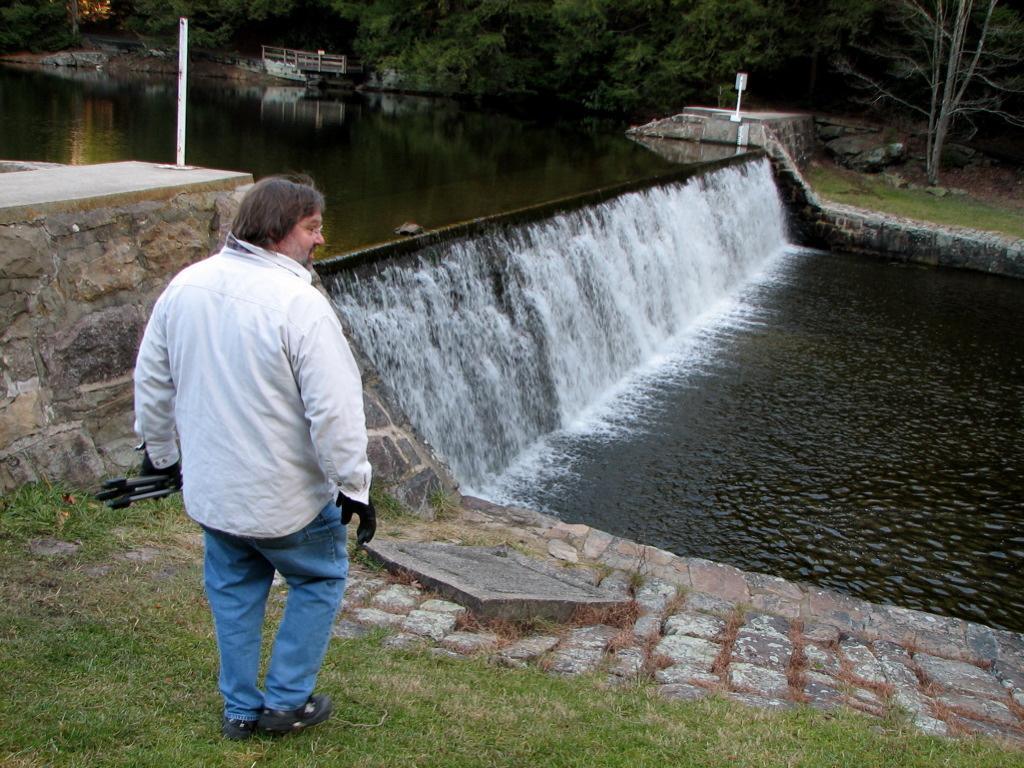Please provide a concise description of this image. In this image we can see a person is standing on the grass on the ground and holding an object in the hand. In the background we can see water, railing, poles on the platform and trees. 